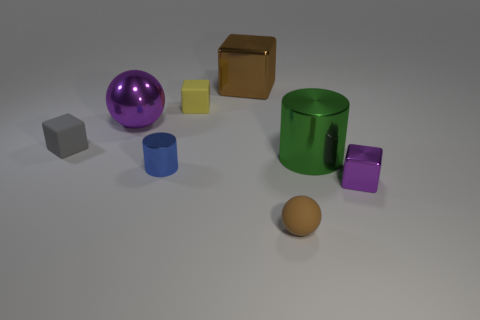Subtract all gray cubes. How many cubes are left? 3 Add 1 rubber balls. How many objects exist? 9 Subtract 1 spheres. How many spheres are left? 1 Subtract all purple blocks. How many blocks are left? 3 Subtract all cylinders. How many objects are left? 6 Subtract all blue cylinders. Subtract all yellow blocks. How many cylinders are left? 1 Subtract all blue cylinders. How many gray cubes are left? 1 Subtract all big cyan balls. Subtract all small blue objects. How many objects are left? 7 Add 8 large purple objects. How many large purple objects are left? 9 Add 4 metallic balls. How many metallic balls exist? 5 